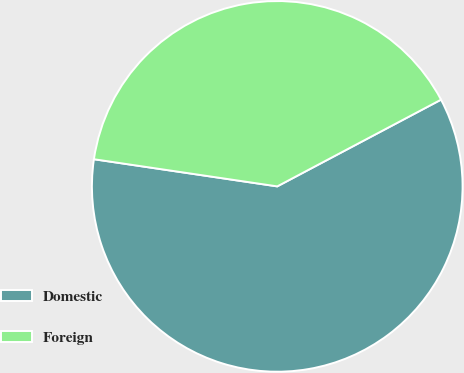Convert chart. <chart><loc_0><loc_0><loc_500><loc_500><pie_chart><fcel>Domestic<fcel>Foreign<nl><fcel>60.09%<fcel>39.91%<nl></chart> 